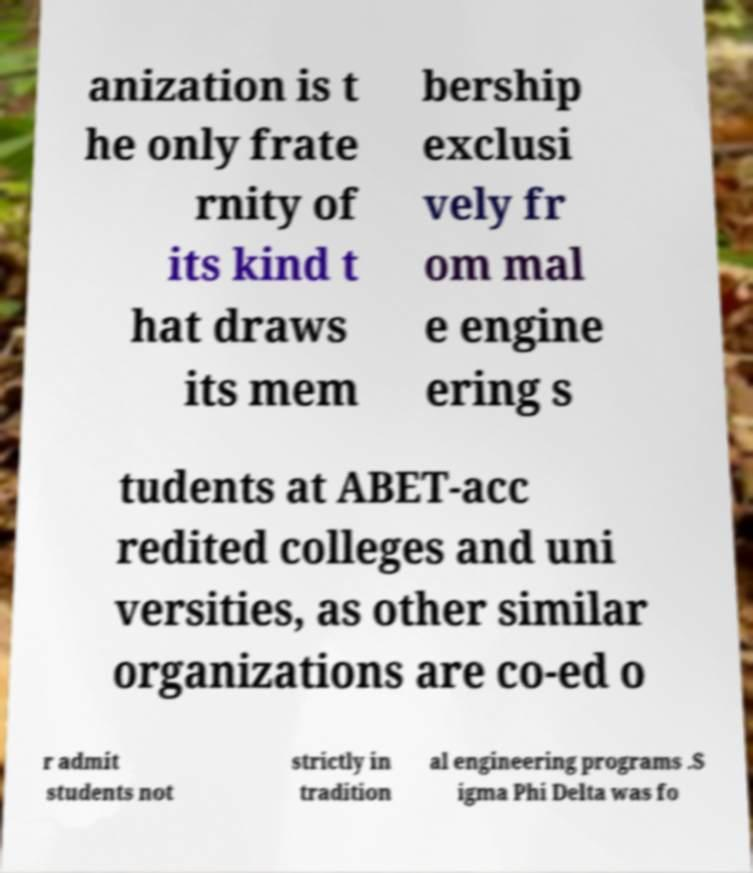I need the written content from this picture converted into text. Can you do that? anization is t he only frate rnity of its kind t hat draws its mem bership exclusi vely fr om mal e engine ering s tudents at ABET-acc redited colleges and uni versities, as other similar organizations are co-ed o r admit students not strictly in tradition al engineering programs .S igma Phi Delta was fo 